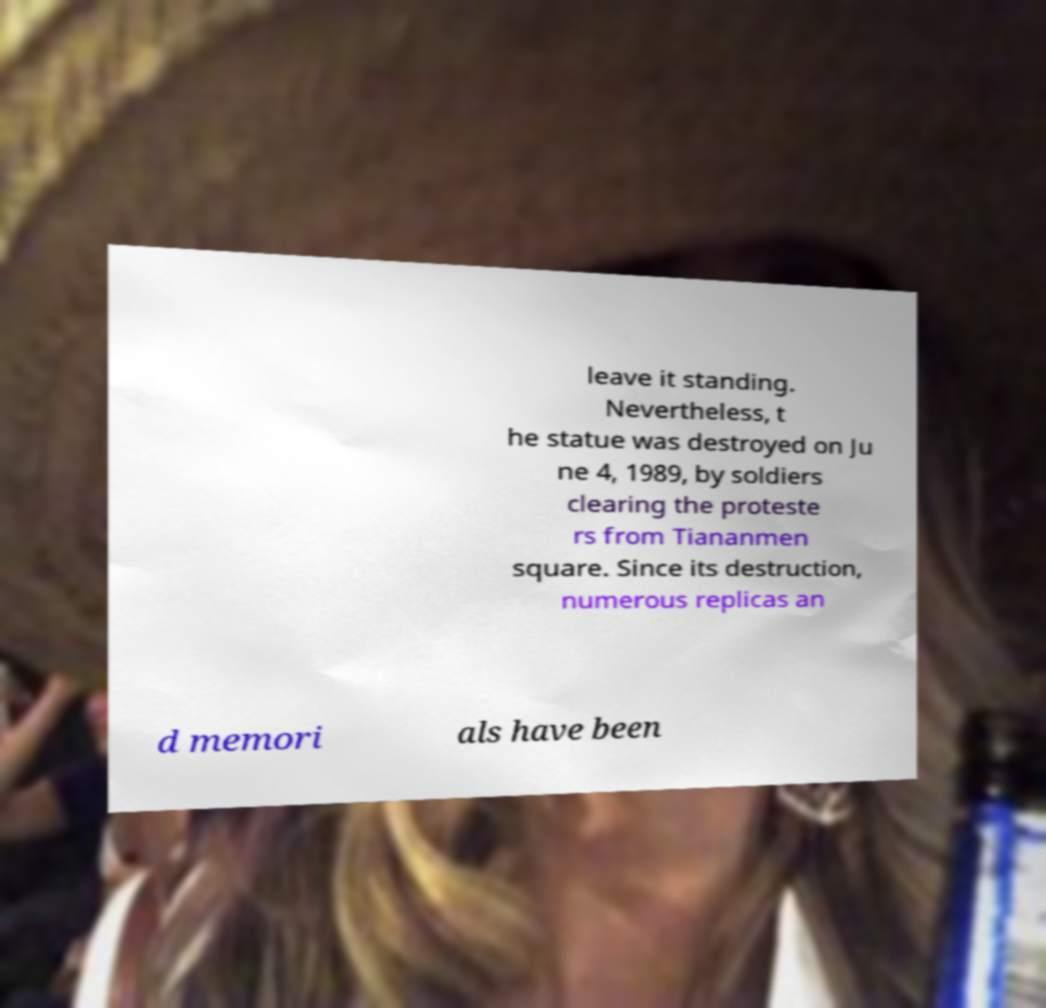Can you read and provide the text displayed in the image?This photo seems to have some interesting text. Can you extract and type it out for me? leave it standing. Nevertheless, t he statue was destroyed on Ju ne 4, 1989, by soldiers clearing the proteste rs from Tiananmen square. Since its destruction, numerous replicas an d memori als have been 